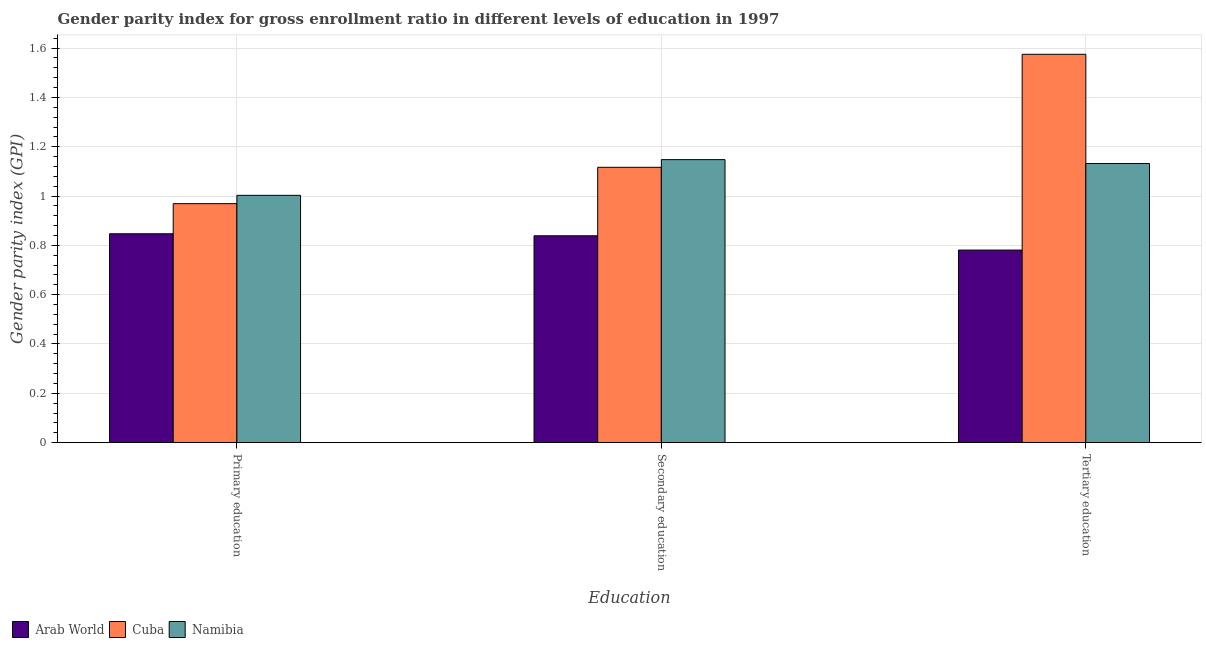Are the number of bars per tick equal to the number of legend labels?
Your answer should be very brief. Yes. Are the number of bars on each tick of the X-axis equal?
Keep it short and to the point. Yes. How many bars are there on the 3rd tick from the right?
Make the answer very short. 3. What is the label of the 2nd group of bars from the left?
Provide a succinct answer. Secondary education. What is the gender parity index in secondary education in Arab World?
Your response must be concise. 0.84. Across all countries, what is the maximum gender parity index in tertiary education?
Offer a very short reply. 1.57. Across all countries, what is the minimum gender parity index in secondary education?
Your answer should be compact. 0.84. In which country was the gender parity index in tertiary education maximum?
Offer a very short reply. Cuba. In which country was the gender parity index in secondary education minimum?
Ensure brevity in your answer.  Arab World. What is the total gender parity index in tertiary education in the graph?
Make the answer very short. 3.49. What is the difference between the gender parity index in primary education in Arab World and that in Namibia?
Your response must be concise. -0.16. What is the difference between the gender parity index in tertiary education in Arab World and the gender parity index in secondary education in Namibia?
Your answer should be compact. -0.37. What is the average gender parity index in tertiary education per country?
Keep it short and to the point. 1.16. What is the difference between the gender parity index in tertiary education and gender parity index in primary education in Cuba?
Offer a terse response. 0.61. What is the ratio of the gender parity index in tertiary education in Cuba to that in Namibia?
Your response must be concise. 1.39. Is the gender parity index in tertiary education in Namibia less than that in Arab World?
Keep it short and to the point. No. What is the difference between the highest and the second highest gender parity index in secondary education?
Provide a short and direct response. 0.03. What is the difference between the highest and the lowest gender parity index in primary education?
Your response must be concise. 0.16. What does the 2nd bar from the left in Primary education represents?
Make the answer very short. Cuba. What does the 2nd bar from the right in Secondary education represents?
Provide a short and direct response. Cuba. How many bars are there?
Keep it short and to the point. 9. What is the difference between two consecutive major ticks on the Y-axis?
Your answer should be very brief. 0.2. Does the graph contain grids?
Offer a terse response. Yes. Where does the legend appear in the graph?
Offer a terse response. Bottom left. How many legend labels are there?
Provide a succinct answer. 3. How are the legend labels stacked?
Offer a terse response. Horizontal. What is the title of the graph?
Provide a succinct answer. Gender parity index for gross enrollment ratio in different levels of education in 1997. Does "Namibia" appear as one of the legend labels in the graph?
Your response must be concise. Yes. What is the label or title of the X-axis?
Offer a very short reply. Education. What is the label or title of the Y-axis?
Make the answer very short. Gender parity index (GPI). What is the Gender parity index (GPI) of Arab World in Primary education?
Ensure brevity in your answer.  0.85. What is the Gender parity index (GPI) in Cuba in Primary education?
Provide a short and direct response. 0.97. What is the Gender parity index (GPI) of Namibia in Primary education?
Your response must be concise. 1. What is the Gender parity index (GPI) in Arab World in Secondary education?
Your answer should be very brief. 0.84. What is the Gender parity index (GPI) of Cuba in Secondary education?
Offer a very short reply. 1.12. What is the Gender parity index (GPI) in Namibia in Secondary education?
Keep it short and to the point. 1.15. What is the Gender parity index (GPI) of Arab World in Tertiary education?
Your answer should be compact. 0.78. What is the Gender parity index (GPI) in Cuba in Tertiary education?
Offer a very short reply. 1.57. What is the Gender parity index (GPI) of Namibia in Tertiary education?
Your answer should be very brief. 1.13. Across all Education, what is the maximum Gender parity index (GPI) of Arab World?
Keep it short and to the point. 0.85. Across all Education, what is the maximum Gender parity index (GPI) in Cuba?
Offer a very short reply. 1.57. Across all Education, what is the maximum Gender parity index (GPI) of Namibia?
Your answer should be very brief. 1.15. Across all Education, what is the minimum Gender parity index (GPI) of Arab World?
Offer a very short reply. 0.78. Across all Education, what is the minimum Gender parity index (GPI) of Cuba?
Offer a very short reply. 0.97. Across all Education, what is the minimum Gender parity index (GPI) in Namibia?
Your response must be concise. 1. What is the total Gender parity index (GPI) in Arab World in the graph?
Give a very brief answer. 2.47. What is the total Gender parity index (GPI) in Cuba in the graph?
Give a very brief answer. 3.66. What is the total Gender parity index (GPI) in Namibia in the graph?
Your answer should be very brief. 3.28. What is the difference between the Gender parity index (GPI) of Arab World in Primary education and that in Secondary education?
Your answer should be compact. 0.01. What is the difference between the Gender parity index (GPI) in Cuba in Primary education and that in Secondary education?
Give a very brief answer. -0.15. What is the difference between the Gender parity index (GPI) in Namibia in Primary education and that in Secondary education?
Ensure brevity in your answer.  -0.14. What is the difference between the Gender parity index (GPI) of Arab World in Primary education and that in Tertiary education?
Your answer should be compact. 0.07. What is the difference between the Gender parity index (GPI) of Cuba in Primary education and that in Tertiary education?
Give a very brief answer. -0.61. What is the difference between the Gender parity index (GPI) of Namibia in Primary education and that in Tertiary education?
Provide a short and direct response. -0.13. What is the difference between the Gender parity index (GPI) in Arab World in Secondary education and that in Tertiary education?
Your answer should be compact. 0.06. What is the difference between the Gender parity index (GPI) of Cuba in Secondary education and that in Tertiary education?
Your response must be concise. -0.46. What is the difference between the Gender parity index (GPI) of Namibia in Secondary education and that in Tertiary education?
Make the answer very short. 0.02. What is the difference between the Gender parity index (GPI) in Arab World in Primary education and the Gender parity index (GPI) in Cuba in Secondary education?
Offer a very short reply. -0.27. What is the difference between the Gender parity index (GPI) in Arab World in Primary education and the Gender parity index (GPI) in Namibia in Secondary education?
Provide a succinct answer. -0.3. What is the difference between the Gender parity index (GPI) of Cuba in Primary education and the Gender parity index (GPI) of Namibia in Secondary education?
Your answer should be compact. -0.18. What is the difference between the Gender parity index (GPI) of Arab World in Primary education and the Gender parity index (GPI) of Cuba in Tertiary education?
Offer a terse response. -0.73. What is the difference between the Gender parity index (GPI) in Arab World in Primary education and the Gender parity index (GPI) in Namibia in Tertiary education?
Offer a terse response. -0.28. What is the difference between the Gender parity index (GPI) of Cuba in Primary education and the Gender parity index (GPI) of Namibia in Tertiary education?
Keep it short and to the point. -0.16. What is the difference between the Gender parity index (GPI) in Arab World in Secondary education and the Gender parity index (GPI) in Cuba in Tertiary education?
Offer a terse response. -0.74. What is the difference between the Gender parity index (GPI) of Arab World in Secondary education and the Gender parity index (GPI) of Namibia in Tertiary education?
Provide a succinct answer. -0.29. What is the difference between the Gender parity index (GPI) in Cuba in Secondary education and the Gender parity index (GPI) in Namibia in Tertiary education?
Your response must be concise. -0.02. What is the average Gender parity index (GPI) of Arab World per Education?
Provide a succinct answer. 0.82. What is the average Gender parity index (GPI) in Cuba per Education?
Offer a terse response. 1.22. What is the average Gender parity index (GPI) of Namibia per Education?
Offer a terse response. 1.09. What is the difference between the Gender parity index (GPI) in Arab World and Gender parity index (GPI) in Cuba in Primary education?
Offer a terse response. -0.12. What is the difference between the Gender parity index (GPI) of Arab World and Gender parity index (GPI) of Namibia in Primary education?
Make the answer very short. -0.16. What is the difference between the Gender parity index (GPI) in Cuba and Gender parity index (GPI) in Namibia in Primary education?
Ensure brevity in your answer.  -0.03. What is the difference between the Gender parity index (GPI) of Arab World and Gender parity index (GPI) of Cuba in Secondary education?
Your answer should be very brief. -0.28. What is the difference between the Gender parity index (GPI) in Arab World and Gender parity index (GPI) in Namibia in Secondary education?
Offer a very short reply. -0.31. What is the difference between the Gender parity index (GPI) of Cuba and Gender parity index (GPI) of Namibia in Secondary education?
Your answer should be very brief. -0.03. What is the difference between the Gender parity index (GPI) in Arab World and Gender parity index (GPI) in Cuba in Tertiary education?
Make the answer very short. -0.79. What is the difference between the Gender parity index (GPI) of Arab World and Gender parity index (GPI) of Namibia in Tertiary education?
Your answer should be very brief. -0.35. What is the difference between the Gender parity index (GPI) in Cuba and Gender parity index (GPI) in Namibia in Tertiary education?
Ensure brevity in your answer.  0.44. What is the ratio of the Gender parity index (GPI) in Arab World in Primary education to that in Secondary education?
Ensure brevity in your answer.  1.01. What is the ratio of the Gender parity index (GPI) of Cuba in Primary education to that in Secondary education?
Keep it short and to the point. 0.87. What is the ratio of the Gender parity index (GPI) of Namibia in Primary education to that in Secondary education?
Ensure brevity in your answer.  0.87. What is the ratio of the Gender parity index (GPI) in Arab World in Primary education to that in Tertiary education?
Your answer should be very brief. 1.08. What is the ratio of the Gender parity index (GPI) in Cuba in Primary education to that in Tertiary education?
Give a very brief answer. 0.62. What is the ratio of the Gender parity index (GPI) of Namibia in Primary education to that in Tertiary education?
Your answer should be very brief. 0.89. What is the ratio of the Gender parity index (GPI) of Arab World in Secondary education to that in Tertiary education?
Keep it short and to the point. 1.07. What is the ratio of the Gender parity index (GPI) of Cuba in Secondary education to that in Tertiary education?
Your response must be concise. 0.71. What is the ratio of the Gender parity index (GPI) in Namibia in Secondary education to that in Tertiary education?
Ensure brevity in your answer.  1.01. What is the difference between the highest and the second highest Gender parity index (GPI) in Arab World?
Your answer should be compact. 0.01. What is the difference between the highest and the second highest Gender parity index (GPI) of Cuba?
Your answer should be very brief. 0.46. What is the difference between the highest and the second highest Gender parity index (GPI) in Namibia?
Ensure brevity in your answer.  0.02. What is the difference between the highest and the lowest Gender parity index (GPI) in Arab World?
Give a very brief answer. 0.07. What is the difference between the highest and the lowest Gender parity index (GPI) of Cuba?
Make the answer very short. 0.61. What is the difference between the highest and the lowest Gender parity index (GPI) of Namibia?
Offer a very short reply. 0.14. 